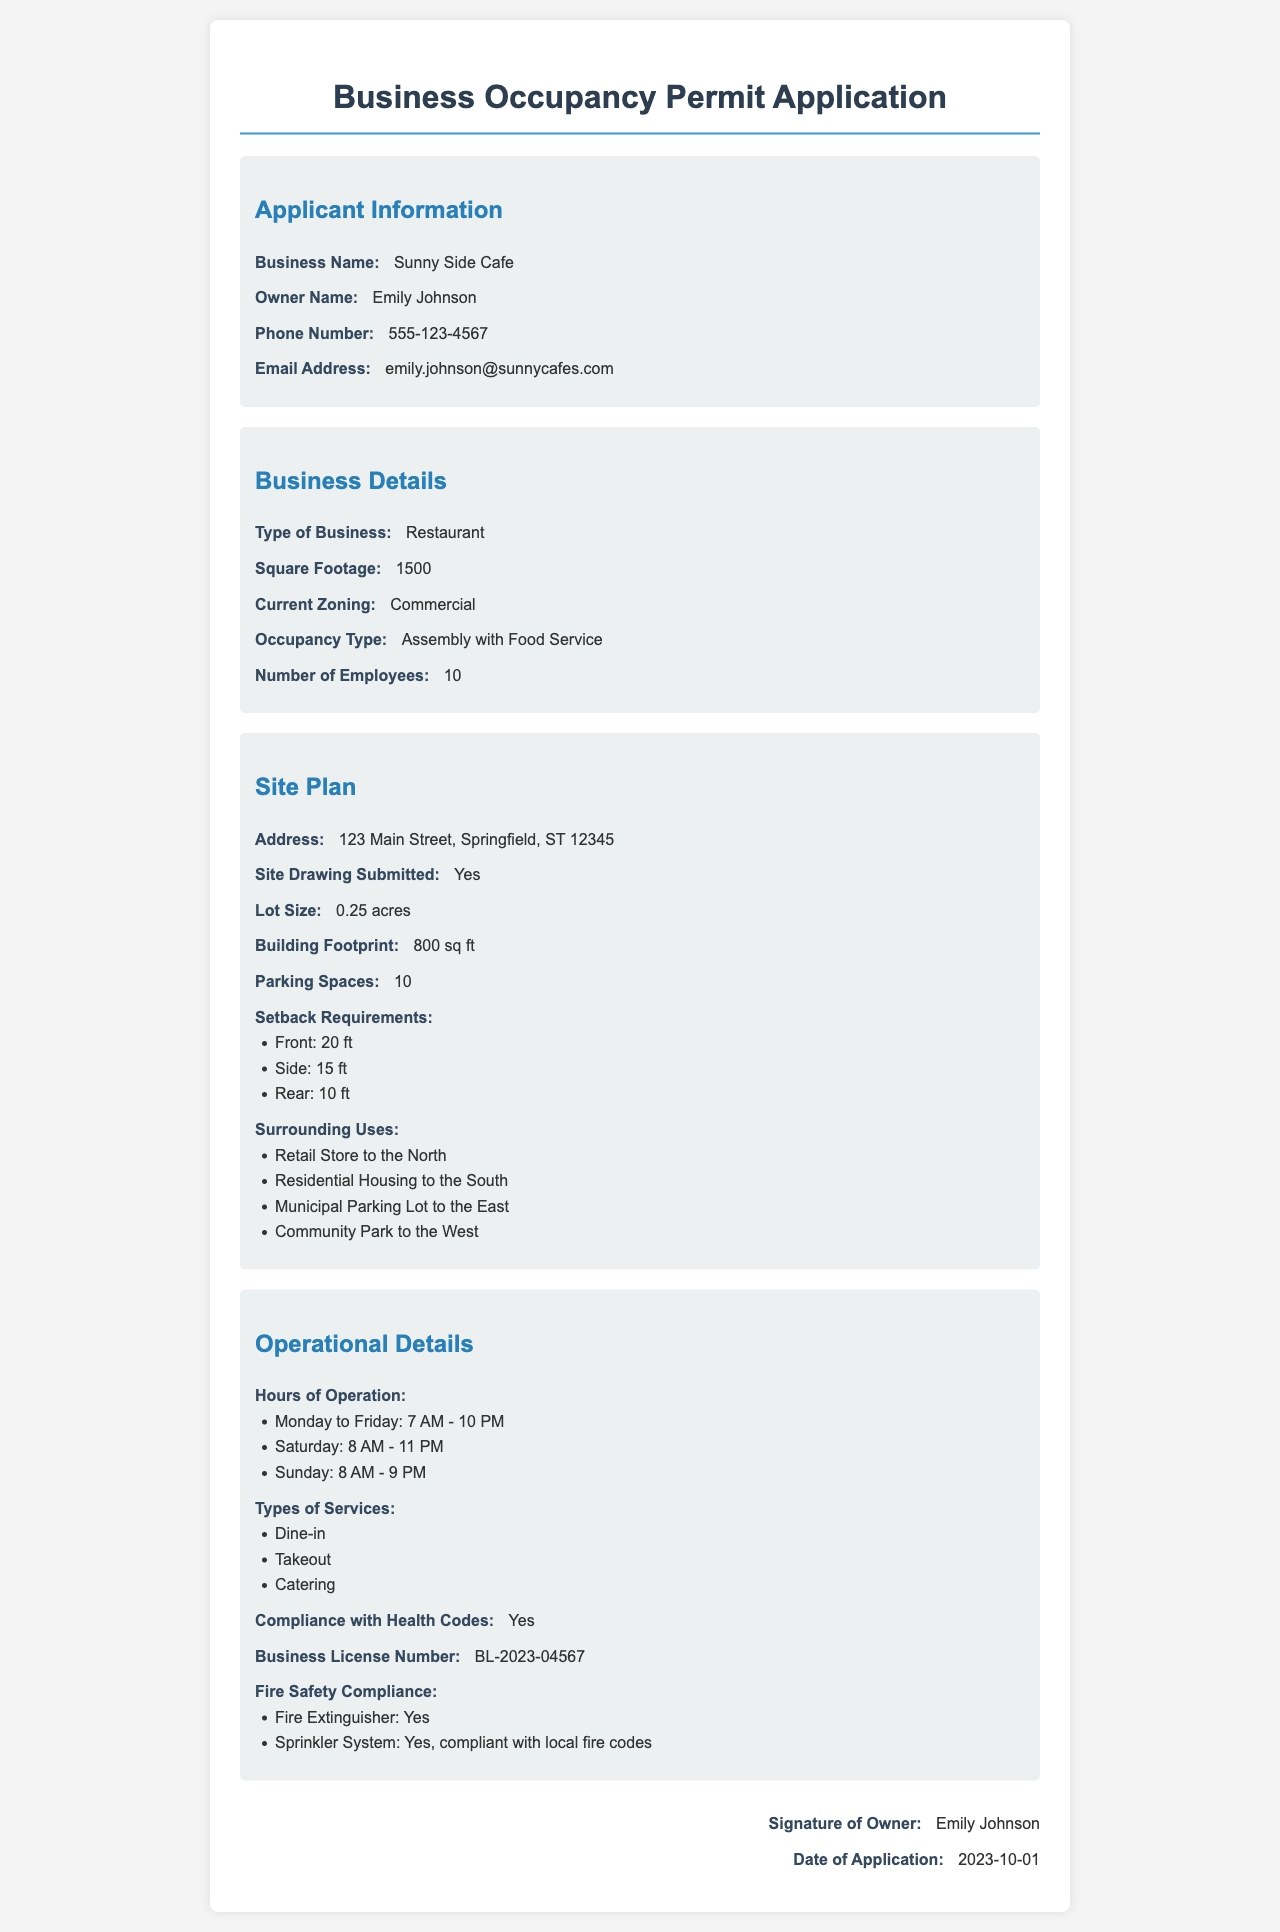What is the business name? The business name is listed under the Applicant Information section.
Answer: Sunny Side Cafe Who is the owner of the business? The owner's name is mentioned in the Applicant Information section.
Answer: Emily Johnson What is the square footage of the restaurant? The square footage is specified under the Business Details section.
Answer: 1500 How many parking spaces are available? The number of parking spaces is found in the Site Plan section.
Answer: 10 What is the business license number? The business license number is included in the Operational Details section.
Answer: BL-2023-04567 What compliance is confirmed in the document? The compliance with health codes is stated under the Operational Details section.
Answer: Yes What is the required front setback? The front setback requirement is included in the Site Plan section.
Answer: 20 ft What types of services does the café offer? The types of services are listed under the Operational Details section.
Answer: Dine-in, Takeout, Catering What is the date of the application? The date of application is provided at the bottom of the document.
Answer: 2023-10-01 